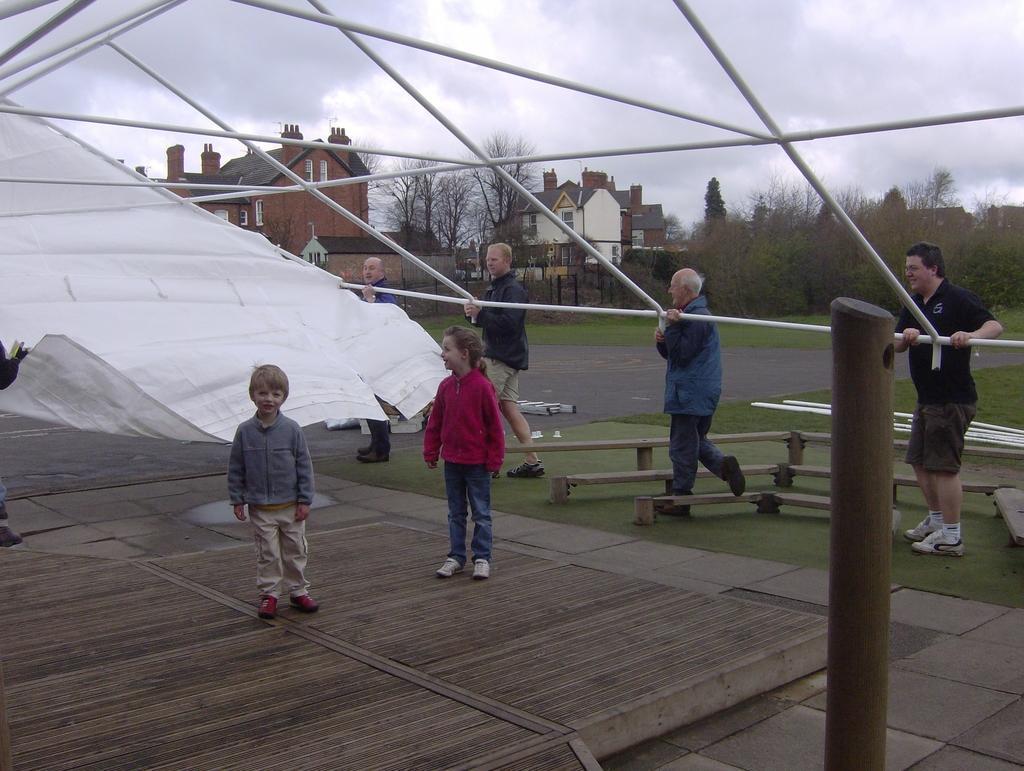How would you summarize this image in a sentence or two? In this image people are standing on the surface of the grass by holding the tent. At the background there are buildings, trees and sky. 